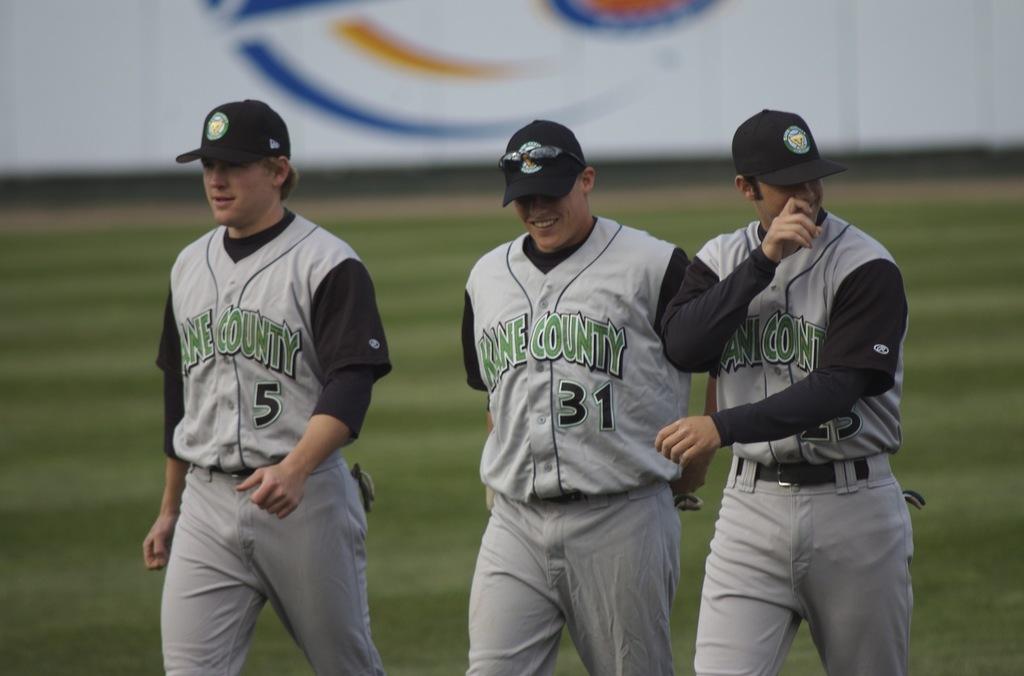What player number is standing in the middle?
Ensure brevity in your answer.  31. What team do they play for?
Give a very brief answer. Kane county. 